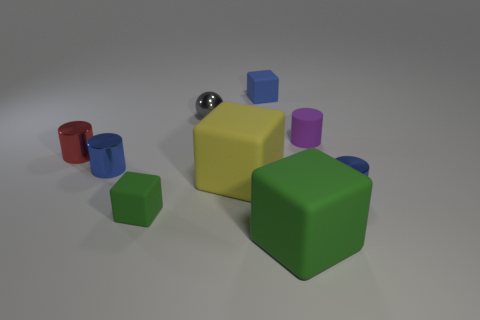Subtract all green cubes. How many were subtracted if there are1green cubes left? 1 Subtract all cyan cubes. Subtract all yellow cylinders. How many cubes are left? 4 Add 1 balls. How many objects exist? 10 Subtract all spheres. How many objects are left? 8 Add 2 metallic things. How many metallic things exist? 6 Subtract 0 purple blocks. How many objects are left? 9 Subtract all gray metallic spheres. Subtract all shiny balls. How many objects are left? 7 Add 5 red metallic things. How many red metallic things are left? 6 